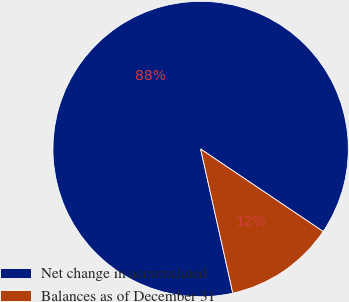Convert chart to OTSL. <chart><loc_0><loc_0><loc_500><loc_500><pie_chart><fcel>Net change in accumulated<fcel>Balances as of December 31<nl><fcel>87.93%<fcel>12.07%<nl></chart> 